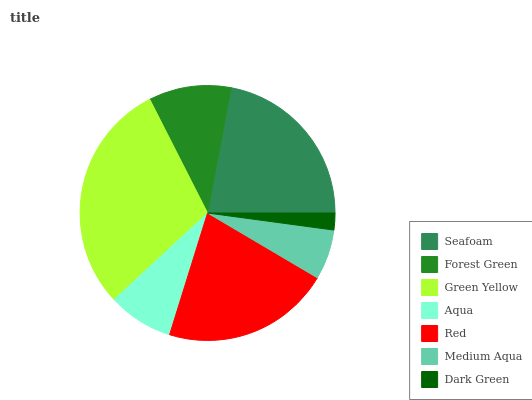Is Dark Green the minimum?
Answer yes or no. Yes. Is Green Yellow the maximum?
Answer yes or no. Yes. Is Forest Green the minimum?
Answer yes or no. No. Is Forest Green the maximum?
Answer yes or no. No. Is Seafoam greater than Forest Green?
Answer yes or no. Yes. Is Forest Green less than Seafoam?
Answer yes or no. Yes. Is Forest Green greater than Seafoam?
Answer yes or no. No. Is Seafoam less than Forest Green?
Answer yes or no. No. Is Forest Green the high median?
Answer yes or no. Yes. Is Forest Green the low median?
Answer yes or no. Yes. Is Seafoam the high median?
Answer yes or no. No. Is Red the low median?
Answer yes or no. No. 